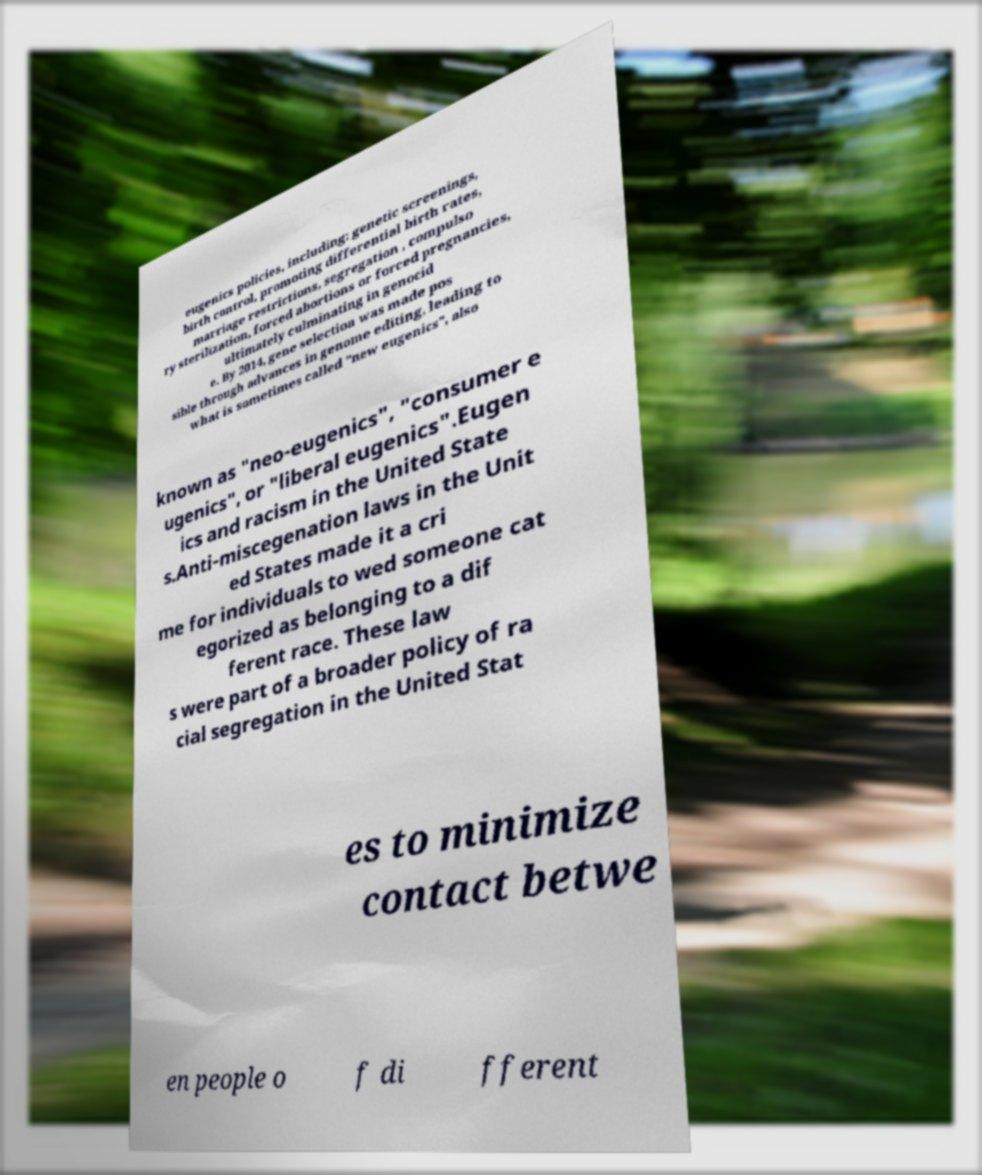Could you extract and type out the text from this image? eugenics policies, including: genetic screenings, birth control, promoting differential birth rates, marriage restrictions, segregation , compulso ry sterilization, forced abortions or forced pregnancies, ultimately culminating in genocid e. By 2014, gene selection was made pos sible through advances in genome editing, leading to what is sometimes called "new eugenics", also known as "neo-eugenics", "consumer e ugenics", or "liberal eugenics".Eugen ics and racism in the United State s.Anti-miscegenation laws in the Unit ed States made it a cri me for individuals to wed someone cat egorized as belonging to a dif ferent race. These law s were part of a broader policy of ra cial segregation in the United Stat es to minimize contact betwe en people o f di fferent 